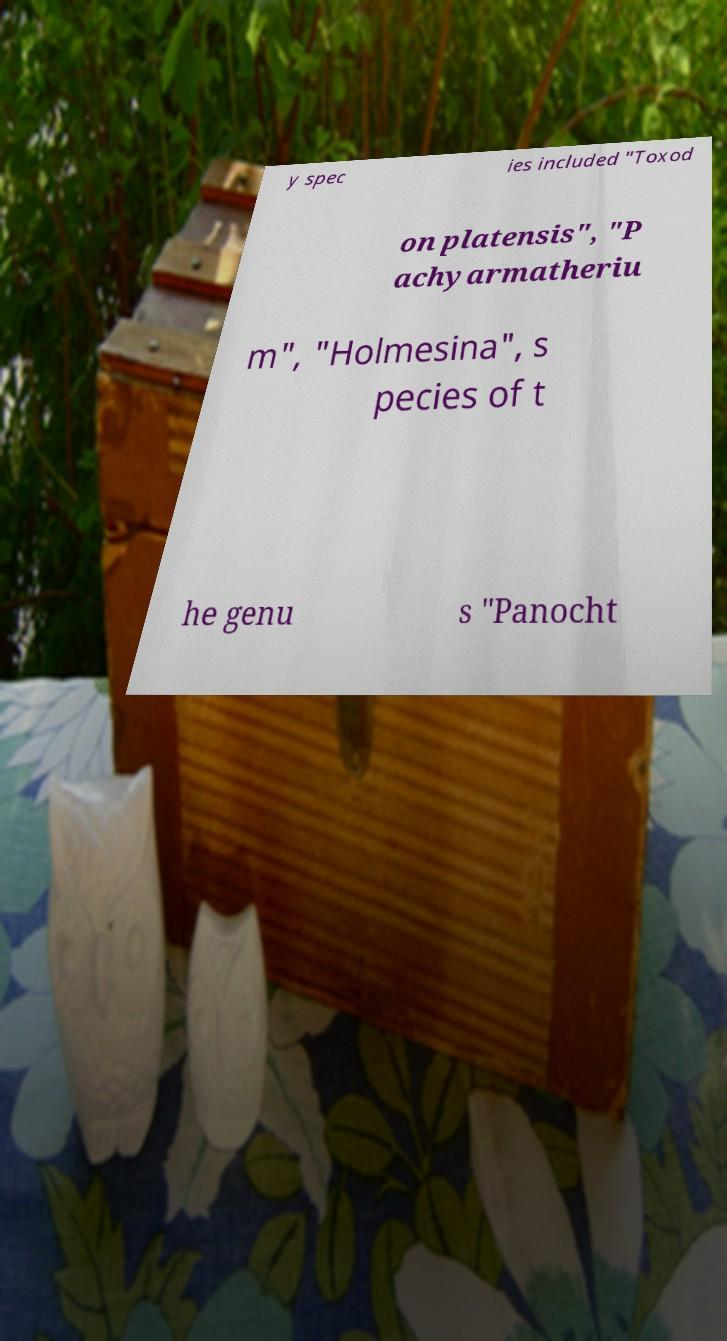Can you read and provide the text displayed in the image?This photo seems to have some interesting text. Can you extract and type it out for me? y spec ies included "Toxod on platensis", "P achyarmatheriu m", "Holmesina", s pecies of t he genu s "Panocht 